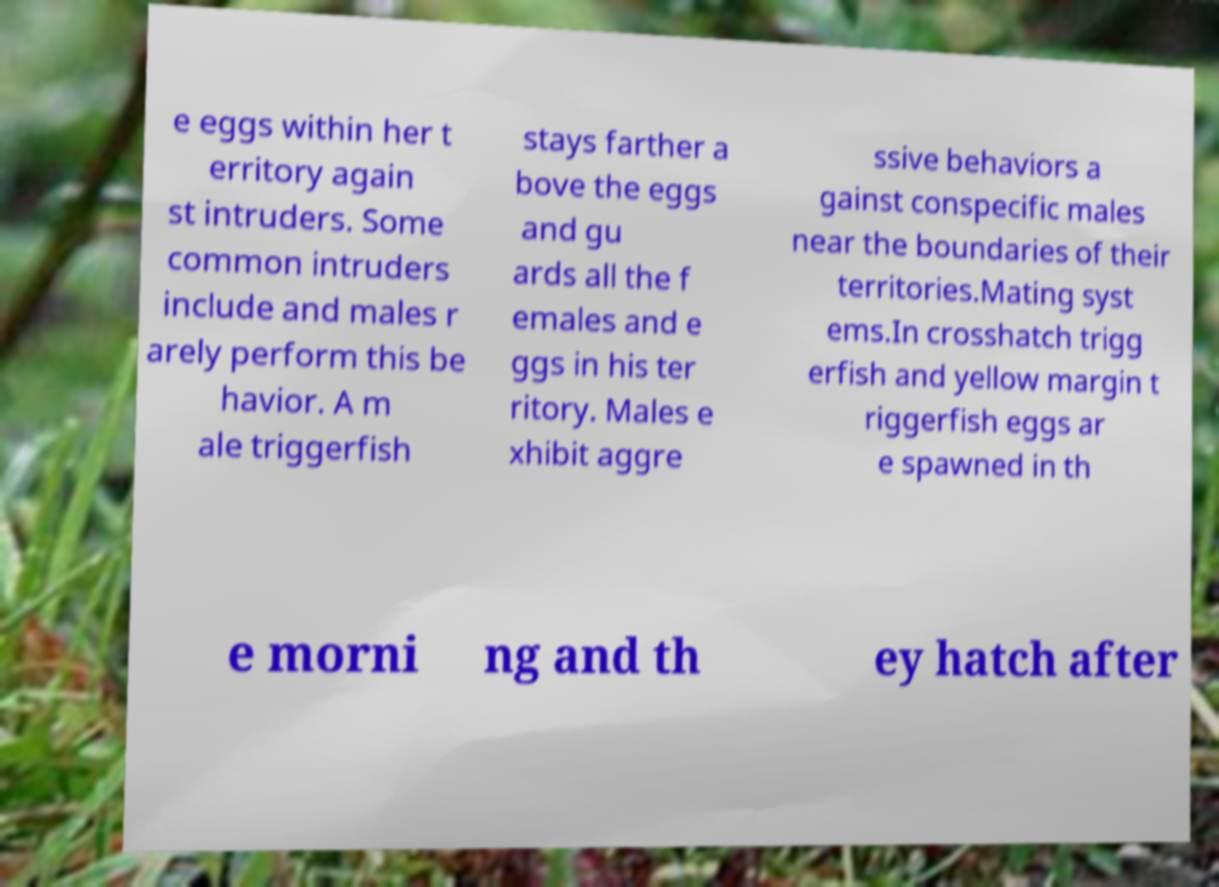Could you assist in decoding the text presented in this image and type it out clearly? e eggs within her t erritory again st intruders. Some common intruders include and males r arely perform this be havior. A m ale triggerfish stays farther a bove the eggs and gu ards all the f emales and e ggs in his ter ritory. Males e xhibit aggre ssive behaviors a gainst conspecific males near the boundaries of their territories.Mating syst ems.In crosshatch trigg erfish and yellow margin t riggerfish eggs ar e spawned in th e morni ng and th ey hatch after 